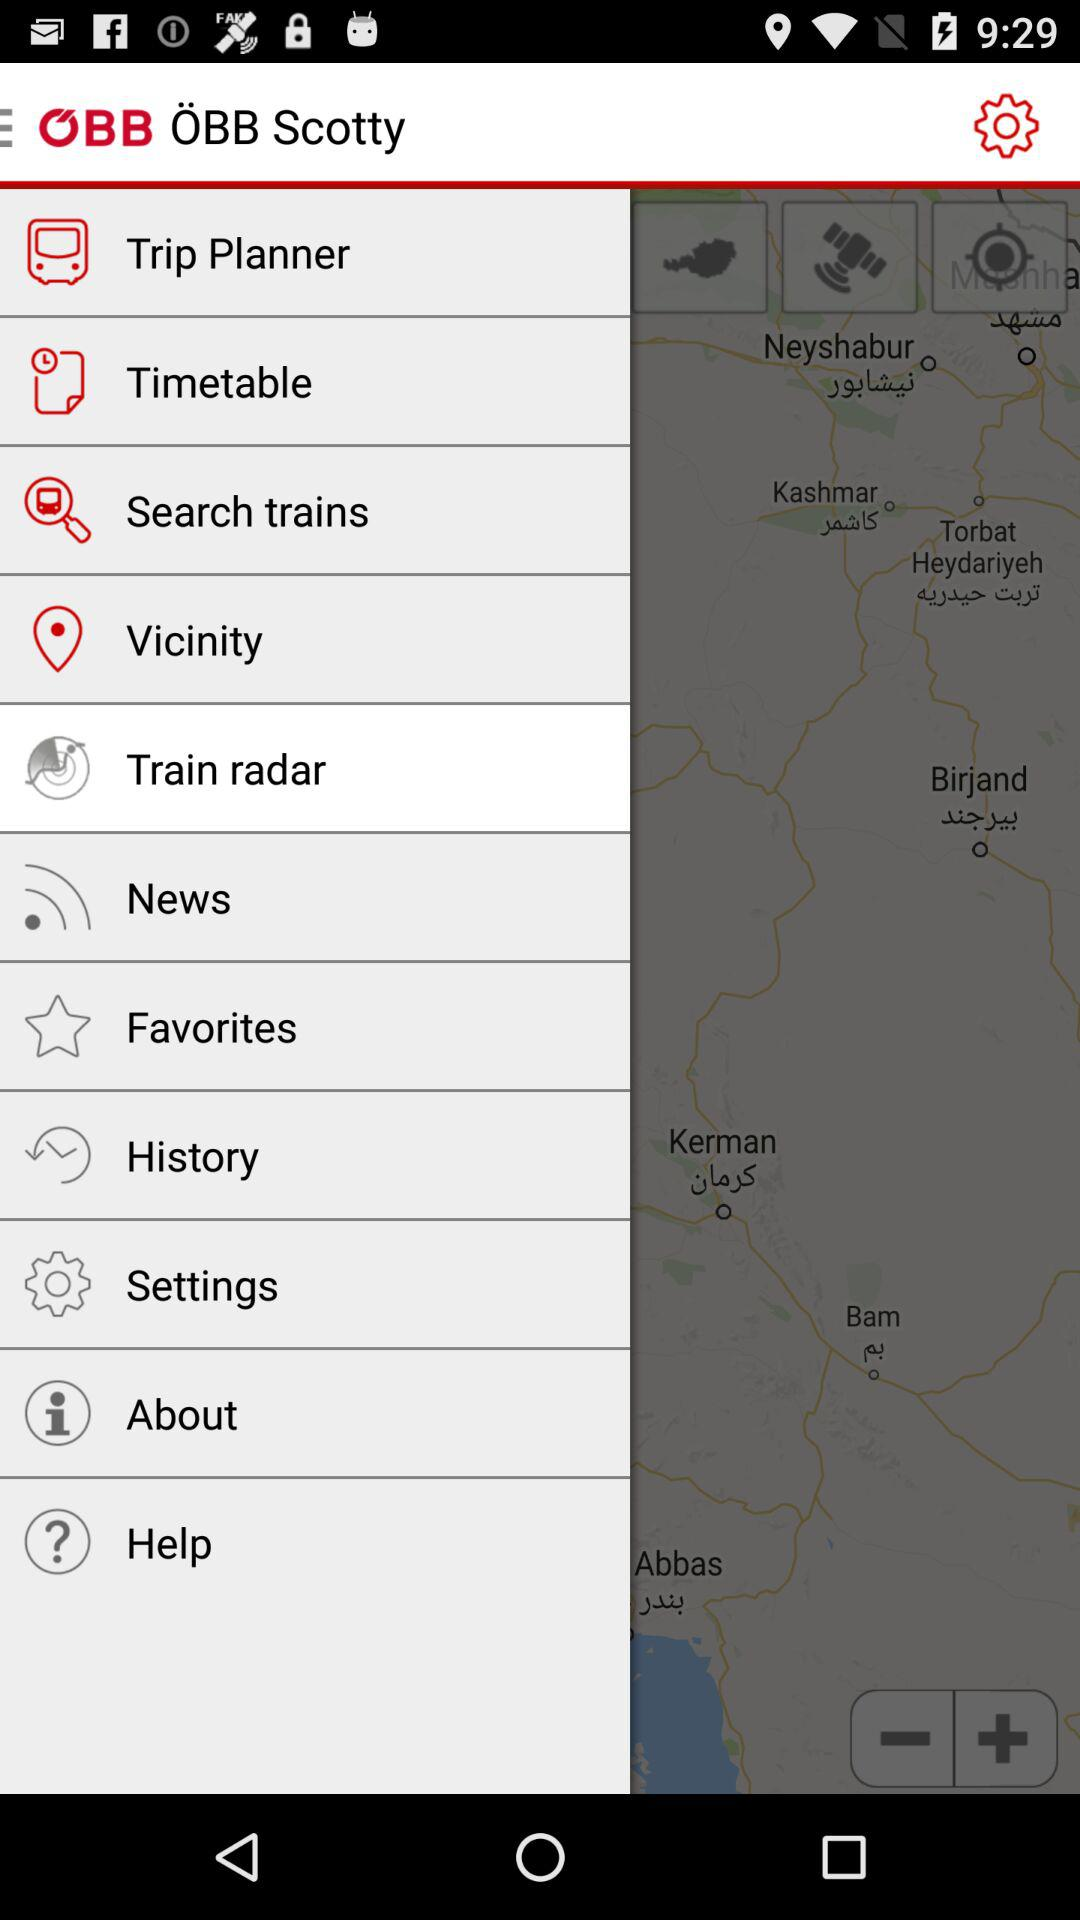How many notifications are there in "Settings"?
When the provided information is insufficient, respond with <no answer>. <no answer> 